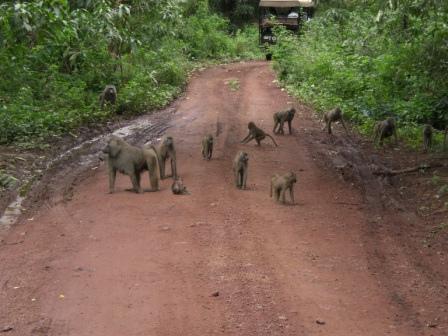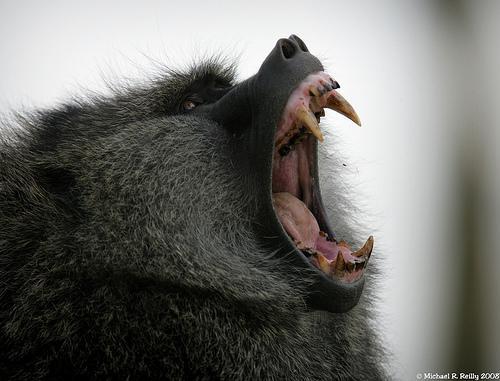The first image is the image on the left, the second image is the image on the right. Evaluate the accuracy of this statement regarding the images: "There is a single animal in the image on the right baring its teeth.". Is it true? Answer yes or no. Yes. 